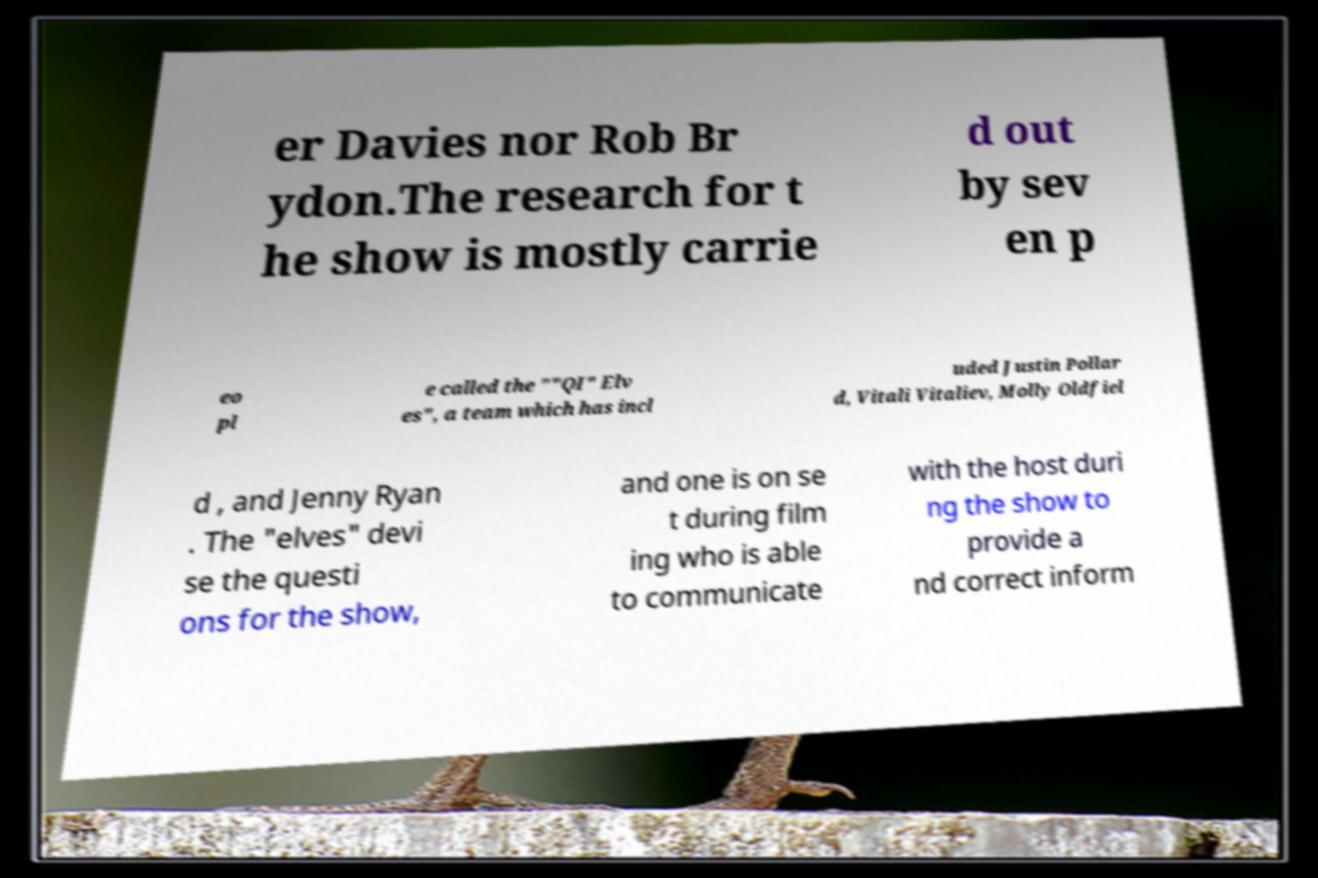There's text embedded in this image that I need extracted. Can you transcribe it verbatim? er Davies nor Rob Br ydon.The research for t he show is mostly carrie d out by sev en p eo pl e called the ""QI" Elv es", a team which has incl uded Justin Pollar d, Vitali Vitaliev, Molly Oldfiel d , and Jenny Ryan . The "elves" devi se the questi ons for the show, and one is on se t during film ing who is able to communicate with the host duri ng the show to provide a nd correct inform 